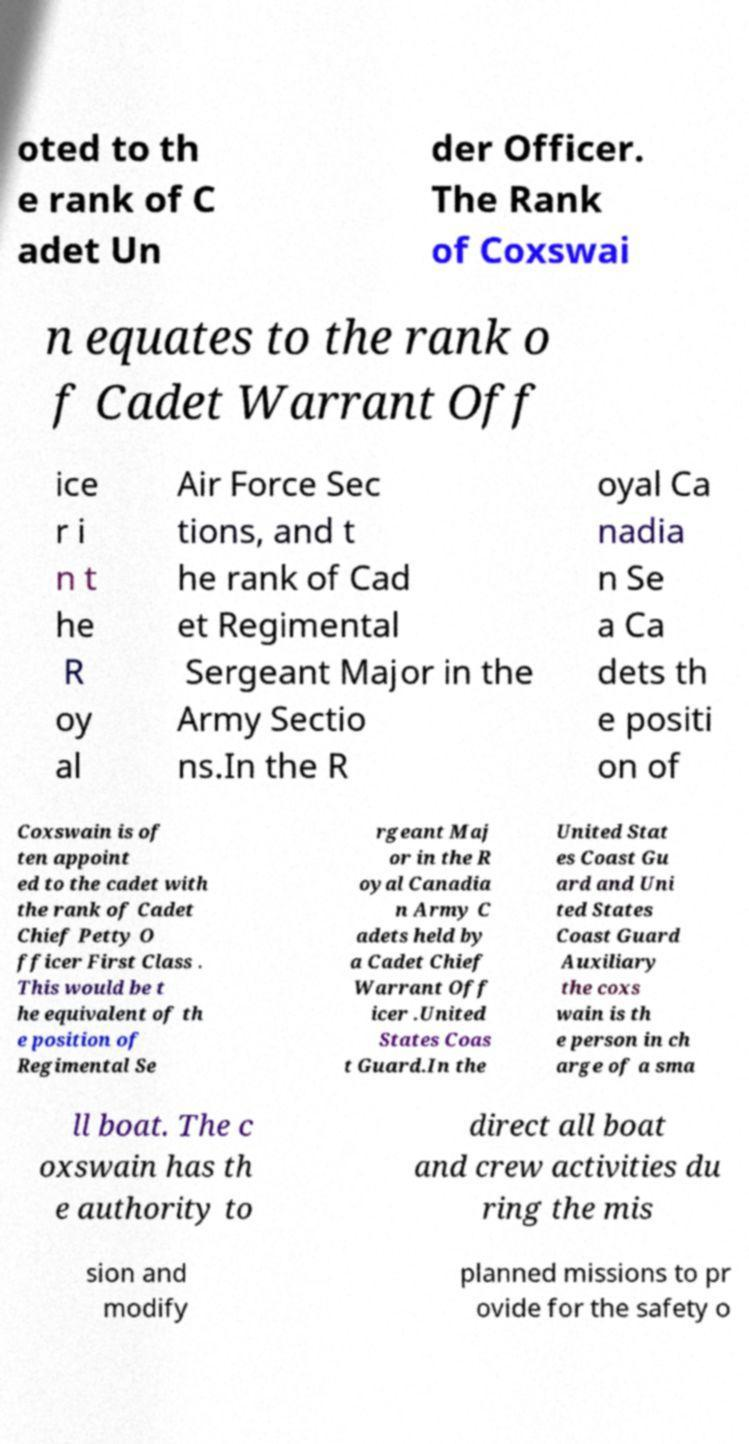Please identify and transcribe the text found in this image. oted to th e rank of C adet Un der Officer. The Rank of Coxswai n equates to the rank o f Cadet Warrant Off ice r i n t he R oy al Air Force Sec tions, and t he rank of Cad et Regimental Sergeant Major in the Army Sectio ns.In the R oyal Ca nadia n Se a Ca dets th e positi on of Coxswain is of ten appoint ed to the cadet with the rank of Cadet Chief Petty O fficer First Class . This would be t he equivalent of th e position of Regimental Se rgeant Maj or in the R oyal Canadia n Army C adets held by a Cadet Chief Warrant Off icer .United States Coas t Guard.In the United Stat es Coast Gu ard and Uni ted States Coast Guard Auxiliary the coxs wain is th e person in ch arge of a sma ll boat. The c oxswain has th e authority to direct all boat and crew activities du ring the mis sion and modify planned missions to pr ovide for the safety o 